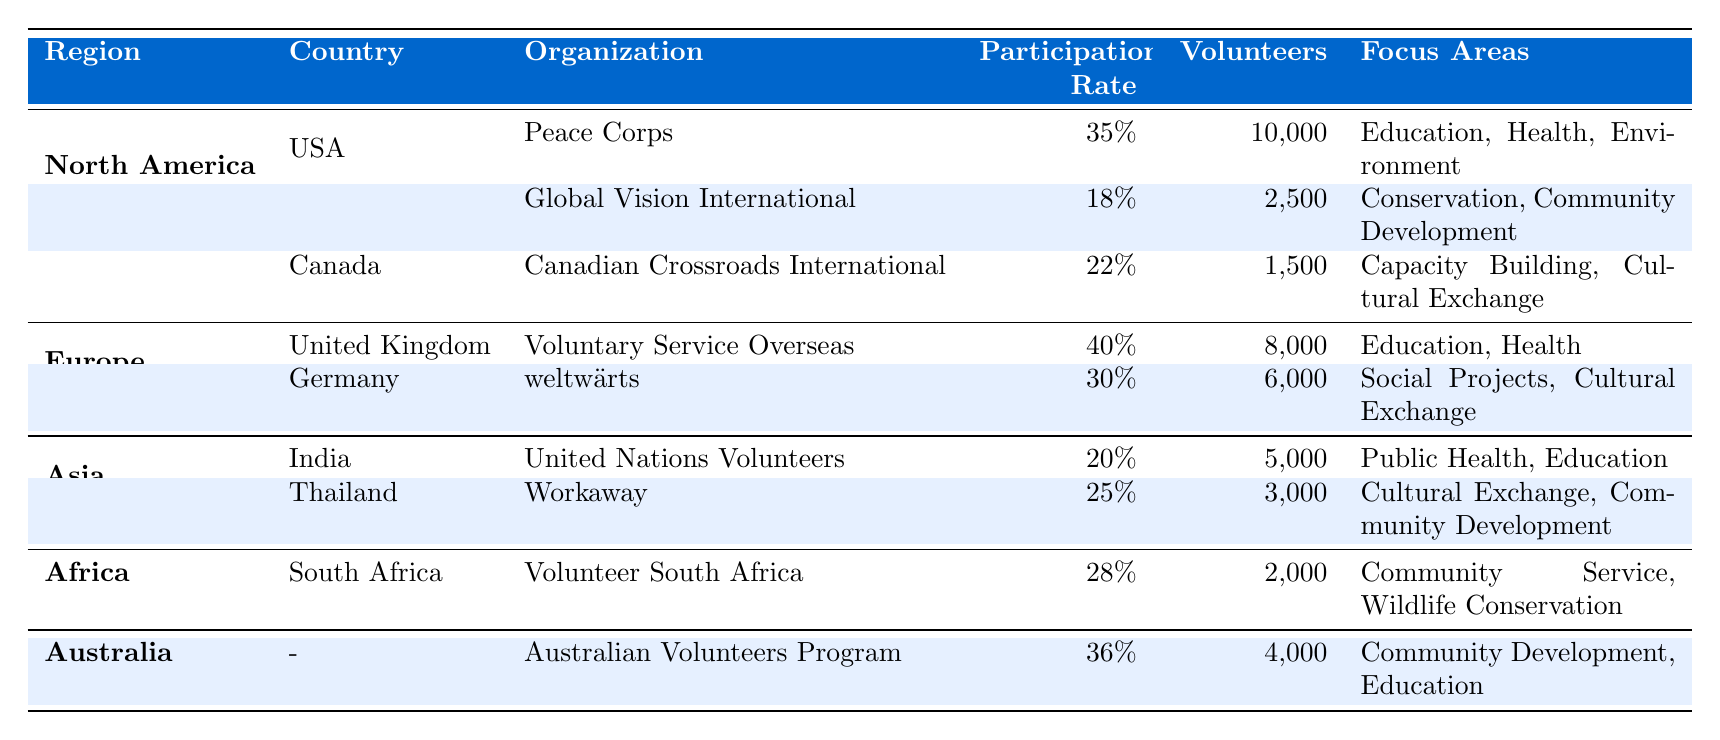What is the participation rate for Peace Corps volunteers in the USA? The table lists "Peace Corps" under the USA section of North America, and the participation rate is directly listed as 35%.
Answer: 35% Which organization has the highest participation rate in Europe? From the Europe section, "Voluntary Service Overseas" has the highest participation rate listed at 40%.
Answer: Voluntary Service Overseas What is the total number of volunteers from organizations in North America? The total volunteers from North America are calculated by summing the number of volunteers: 10,000 (Peace Corps) + 2,500 (Global Vision International) + 1,500 (Canadian Crossroads International) = 14,000.
Answer: 14,000 Is the participation rate for Workaway in Thailand higher than that for United Nations Volunteers in India? The participation rate for Workaway is 25% while for United Nations Volunteers, it is 20%. Since 25% is greater than 20%, the statement is true.
Answer: Yes What is the average participation rate for the organizations listed in Africa and Australia? Africa has one organization (Volunteer South Africa) with a participation rate of 28%, while Australia has one organization (Australian Volunteers Program) with a rate of 36%. The average is calculated as (28% + 36%) / 2 = 32%.
Answer: 32% Which region has the least number of volunteers across all its organizations? North America has 14,000 total volunteers, Europe has 14,000, Asia has 8,000, Africa has 2,000, and Australia has 4,000. The region with the least volunteers is Africa with 2,000 total volunteers.
Answer: Africa How many focus areas does Global Vision International focus on? The table shows that Global Vision International has two focus areas listed: Conservation and Community Development.
Answer: 2 Are there any organizations focused on wildlife conservation? The table indicates that "Volunteer South Africa" focuses on wildlife conservation. Therefore, the answer is yes.
Answer: Yes What is the difference in volunteer numbers between Voluntary Service Overseas in the United Kingdom and weltwärts in Germany? The number of volunteers for Voluntary Service Overseas is 8,000 and for weltwärts is 6,000. The difference is 8,000 - 6,000 = 2,000.
Answer: 2,000 